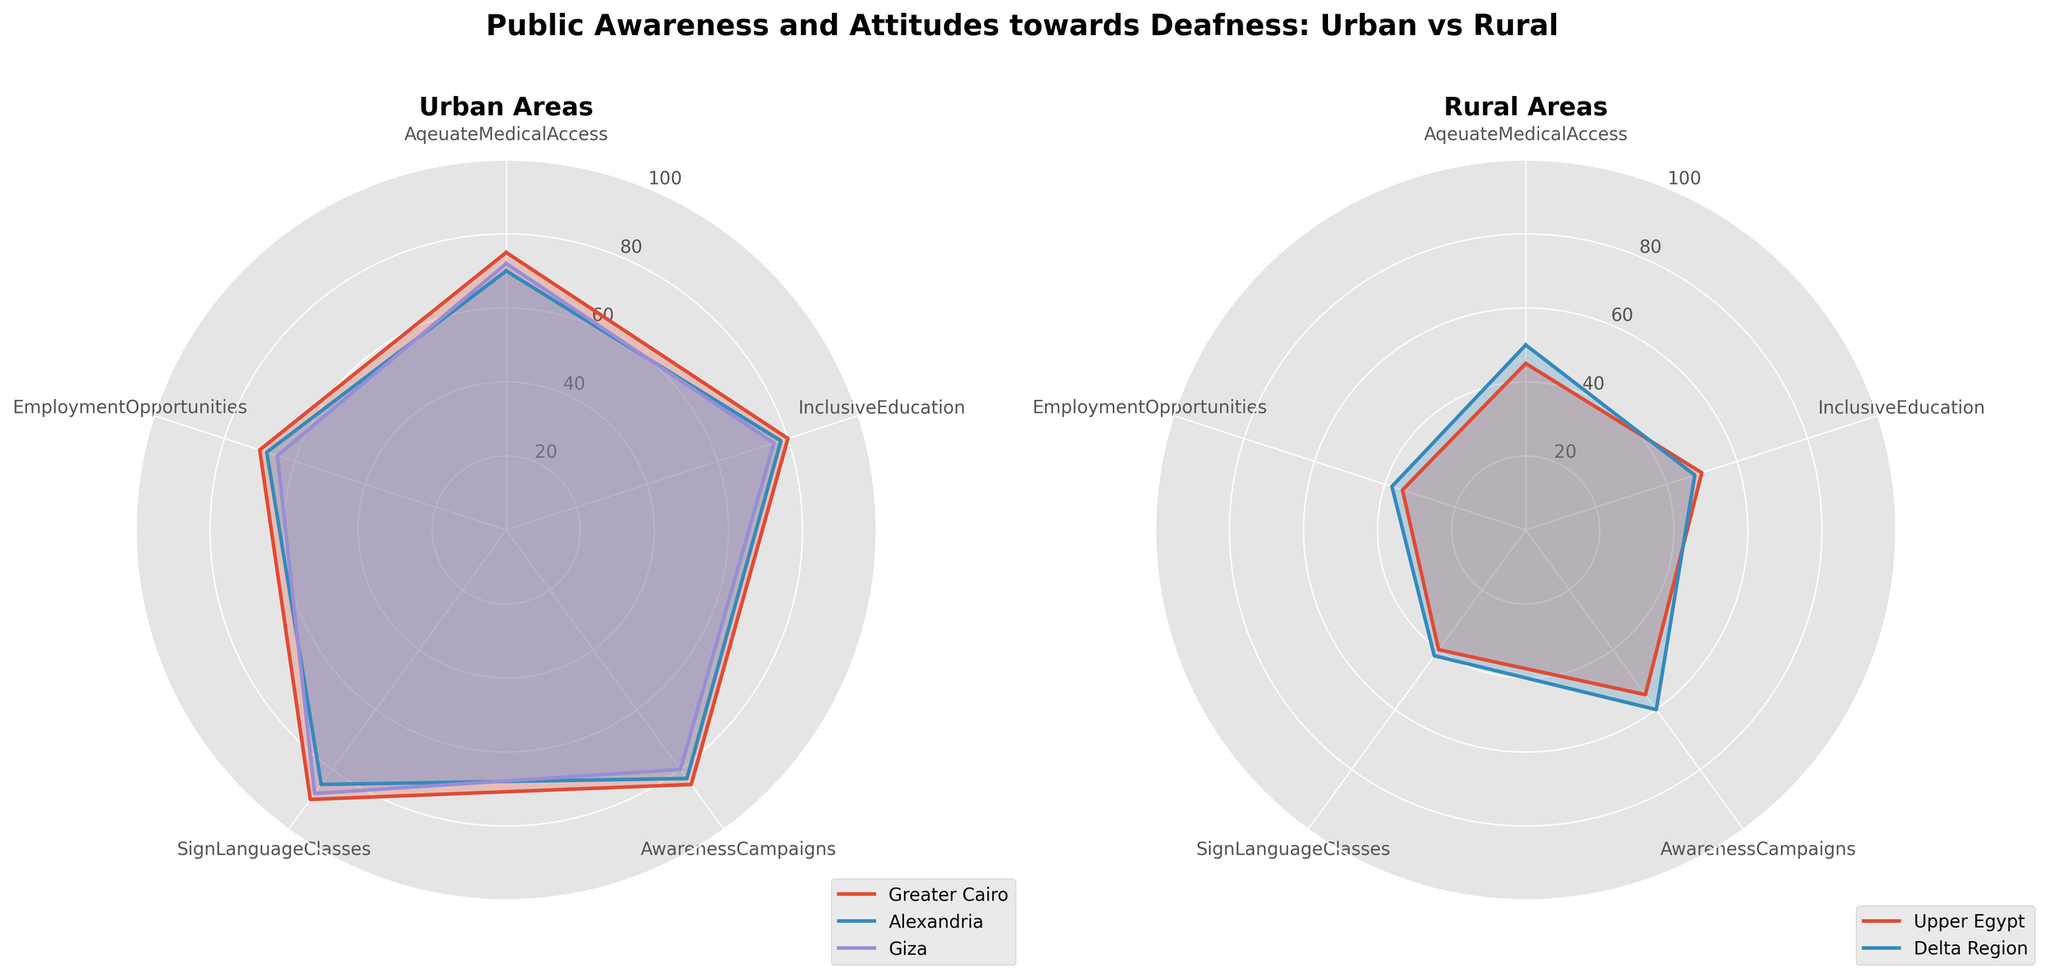What areas are compared in the charts? The radar charts compare two major areas: "Urban" areas including Greater Cairo, Alexandria, and Giza, and "Rural" areas including Upper Egypt and Delta Region.
Answer: Urban and Rural Which urban area scored the highest in "Sign Language Classes"? By examining the "Urban" radar chart, we observe that Greater Cairo has the highest value of 90 for "Sign Language Classes".
Answer: Greater Cairo What is the difference in "Adequate Medical Access" between Greater Cairo and Upper Egypt? Greater Cairo scores 75 in "Adequate Medical Access" while Upper Egypt scores 45. The difference is calculated by subtracting 45 from 75.
Answer: 30 In which aspect do rural areas perform worst? From the radar chart for "Rural" areas, Upper Egypt scores the lowest in "Sign Language Classes" with a value of 40.
Answer: Sign Language Classes What is the average score of "Employment Opportunities" for the three urban areas? The scores for "Employment Opportunities" are 70 (Greater Cairo), 68 (Alexandria), and 65 (Giza). Sum these values and divide by 3 to get the average: (70 + 68 + 65)/3 = 67.67.
Answer: 67.67 Which has a higher average score across all aspects, Urban or Rural? First, calculate the average score for each category for Urban and Rural. Urban scores across 5 aspects are [75+70+72, 80+78+76, 85+83+80, 90+85+88, 70+68+65], sum all and divide by 15. Rural scores [45+50, 50+48, 55+60, 40+42, 35+38], sum all and divide by 10. Urban average is 1778/15 ≈ 118.53, Rural average is 413/10 ≈ 41.3.
Answer: Urban Which rural area performed better in "Awareness Campaigns"? By inspecting the rural radar chart, Delta Region scores 60 in "Awareness Campaigns" whereas Upper Egypt scores 55.
Answer: Delta Region 